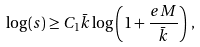Convert formula to latex. <formula><loc_0><loc_0><loc_500><loc_500>\log ( s ) \geq C _ { 1 } \bar { k } \log \left ( 1 + \frac { e M } { \bar { k } } \right ) \, ,</formula> 